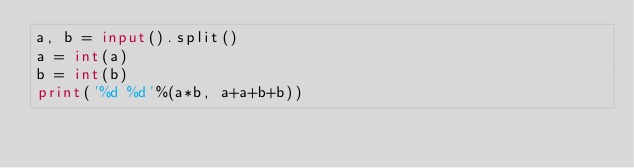<code> <loc_0><loc_0><loc_500><loc_500><_Python_>a, b = input().split()
a = int(a)
b = int(b)
print('%d %d'%(a*b, a+a+b+b))
</code> 